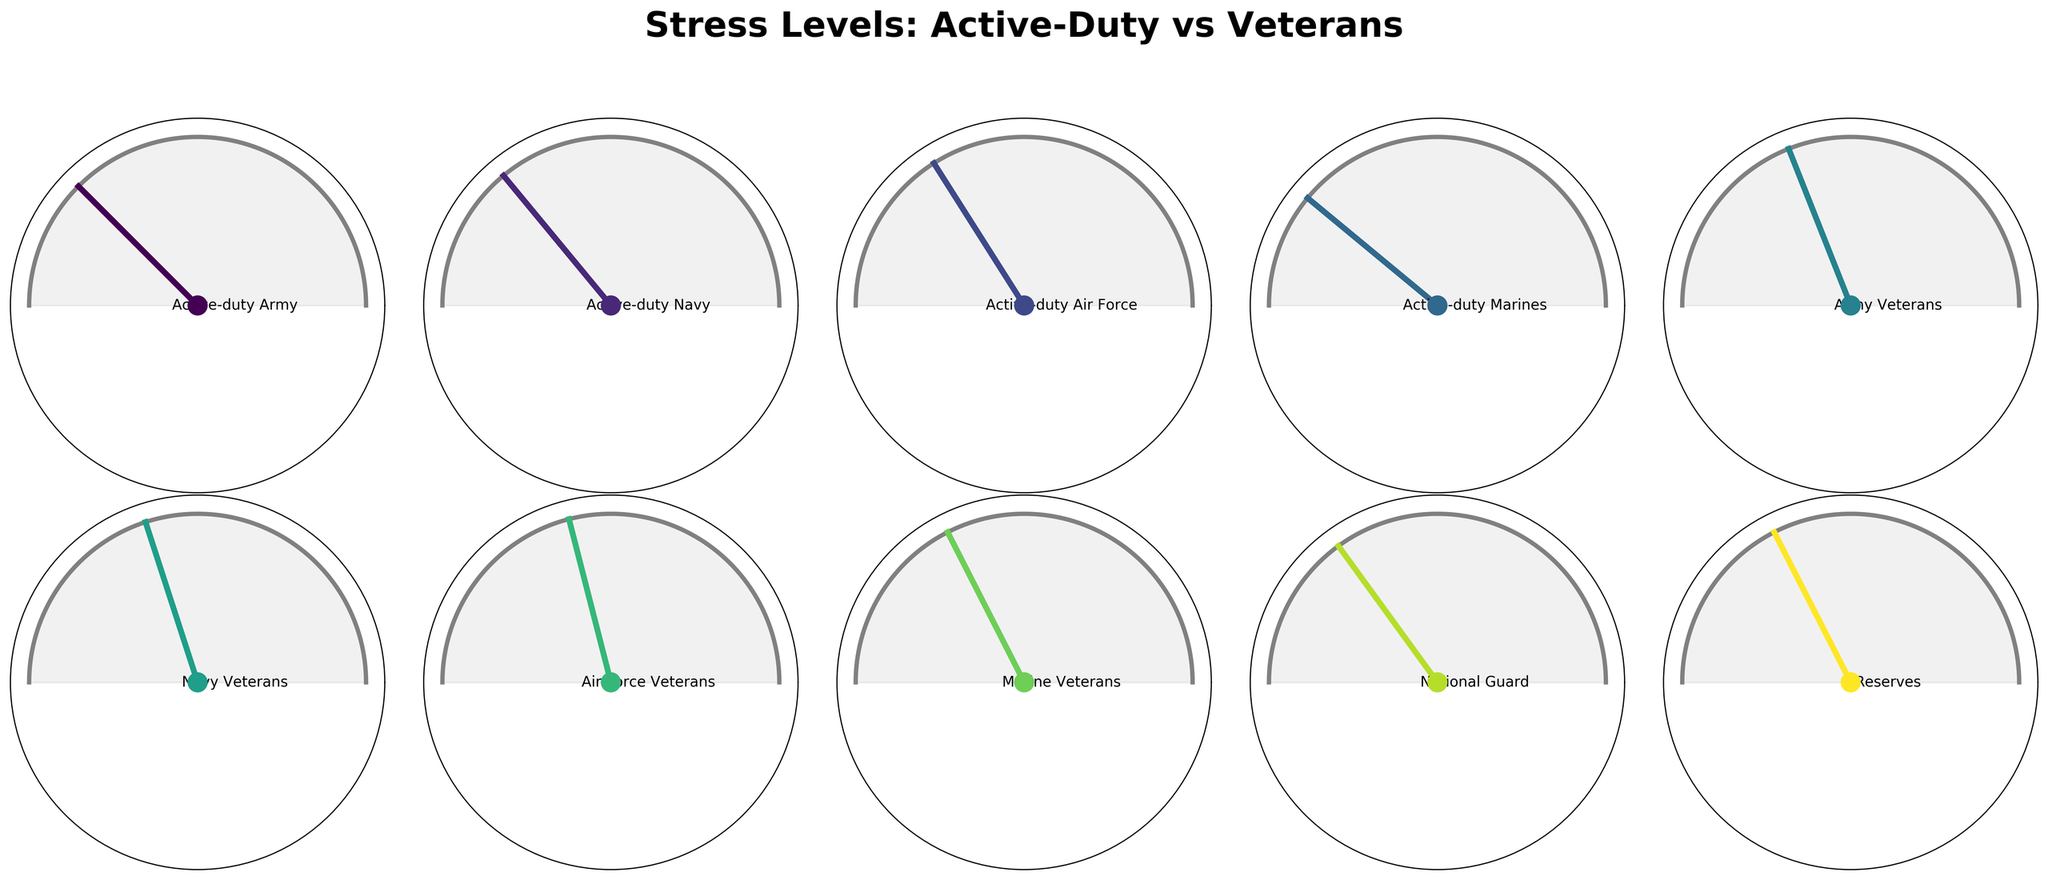What is the stress level for active-duty Army personnel? Look at the gauge chart for active-duty Army personnel and read the value indicated by the needle.
Answer: 75% Which category has the highest stress level? Compare the stress levels for each category shown in the corresponding gauge charts. The category with the highest indicated value is the one.
Answer: Active-duty Marines What is the difference in stress levels between active-duty Marines and Marine veterans? Look at the stress levels for both categories. The difference is calculated by subtracting the stress level of Marine veterans from that of active-duty Marines. 78 - 65 = 13.
Answer: 13 Which group among the veterans has the lowest stress level? Compare the stress levels of the veteran categories (Army, Navy, Air Force, Marine). The category with the lowest indicated stress level is the answer.
Answer: Air Force Veterans How many categories have a stress level above 70? Count the number of categories where the stress level indicated by the gauge chart is greater than 70.
Answer: 5 What is the average stress level for all active-duty personnel? Sum the stress levels of all active-duty categories (Army, Navy, Air Force, Marines) and divide by 4. (75 + 72 + 68 + 78) / 4 = 73.25.
Answer: 73.25 What is the title of the plot? Look at the top of the plot where the title is usually displayed.
Answer: Stress Levels: Active-Duty vs Veterans Which group has the closest stress level to National Guard personnel? Compare the stress levels of National Guard personnel to other groups and find the one closest in value. National Guard: 70. The closest value is the Army Veterans with a stress level of 62.
Answer: Army Veterans What is the overall range of stress levels in this plot? Identify the maximum and minimum stress levels from the chart and calculate the range by subtracting the minimum from the maximum. The maximum is 78 (active-duty Marines), and the minimum is 58 (Air Force Veterans). Range = 78 - 58.
Answer: 20 Between active-duty Navy and Navy veterans, which has a higher stress level and by how much? Compare the stress levels for active-duty Navy (72) and Navy Veterans (60). The difference is 72 - 60 = 12.
Answer: Active-duty Navy by 12 